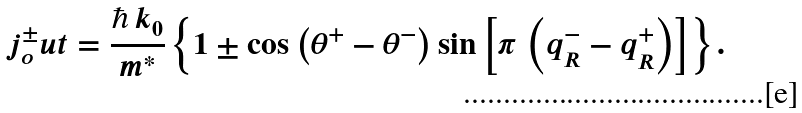Convert formula to latex. <formula><loc_0><loc_0><loc_500><loc_500>j ^ { \pm } _ { o } u t = \frac { \hbar { \, } k _ { 0 } } { m ^ { * } } \left \{ 1 \pm \cos \left ( \theta ^ { + } - \theta ^ { - } \right ) \sin \left [ \pi \, \left ( q ^ { - } _ { R } - q ^ { + } _ { R } \right ) \right ] \right \} .</formula> 